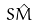<formula> <loc_0><loc_0><loc_500><loc_500>S \hat { M }</formula> 